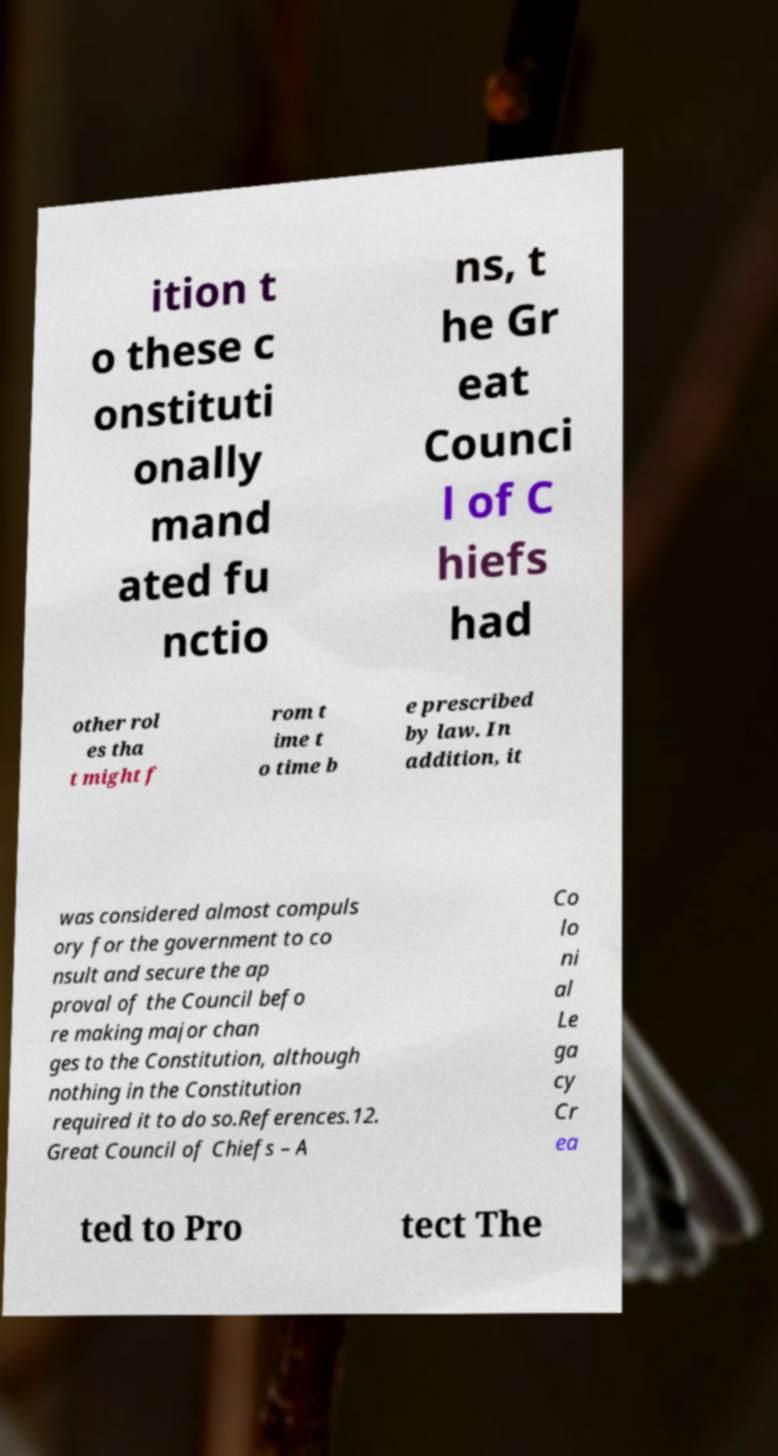There's text embedded in this image that I need extracted. Can you transcribe it verbatim? ition t o these c onstituti onally mand ated fu nctio ns, t he Gr eat Counci l of C hiefs had other rol es tha t might f rom t ime t o time b e prescribed by law. In addition, it was considered almost compuls ory for the government to co nsult and secure the ap proval of the Council befo re making major chan ges to the Constitution, although nothing in the Constitution required it to do so.References.12. Great Council of Chiefs – A Co lo ni al Le ga cy Cr ea ted to Pro tect The 